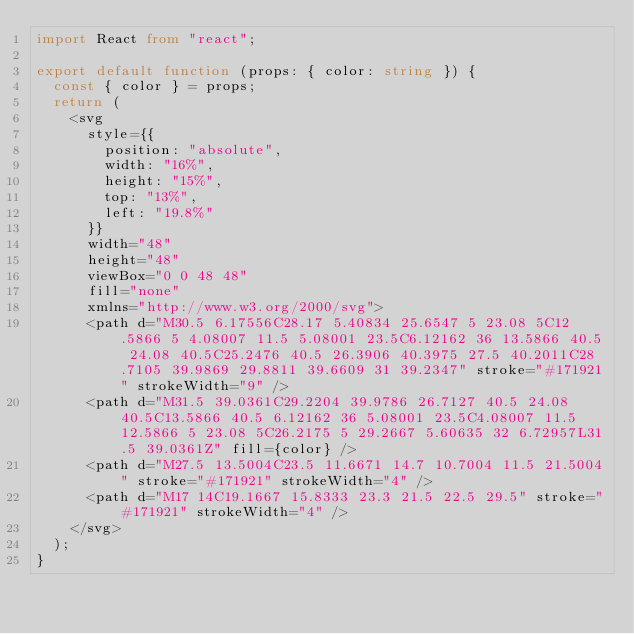Convert code to text. <code><loc_0><loc_0><loc_500><loc_500><_TypeScript_>import React from "react";

export default function (props: { color: string }) {
  const { color } = props;
  return (
    <svg
      style={{
        position: "absolute",
        width: "16%",
        height: "15%",
        top: "13%",
        left: "19.8%"
      }}
      width="48"
      height="48"
      viewBox="0 0 48 48"
      fill="none"
      xmlns="http://www.w3.org/2000/svg">
      <path d="M30.5 6.17556C28.17 5.40834 25.6547 5 23.08 5C12.5866 5 4.08007 11.5 5.08001 23.5C6.12162 36 13.5866 40.5 24.08 40.5C25.2476 40.5 26.3906 40.3975 27.5 40.2011C28.7105 39.9869 29.8811 39.6609 31 39.2347" stroke="#171921" strokeWidth="9" />
      <path d="M31.5 39.0361C29.2204 39.9786 26.7127 40.5 24.08 40.5C13.5866 40.5 6.12162 36 5.08001 23.5C4.08007 11.5 12.5866 5 23.08 5C26.2175 5 29.2667 5.60635 32 6.72957L31.5 39.0361Z" fill={color} />
      <path d="M27.5 13.5004C23.5 11.6671 14.7 10.7004 11.5 21.5004" stroke="#171921" strokeWidth="4" />
      <path d="M17 14C19.1667 15.8333 23.3 21.5 22.5 29.5" stroke="#171921" strokeWidth="4" />
    </svg>
  );
}
</code> 